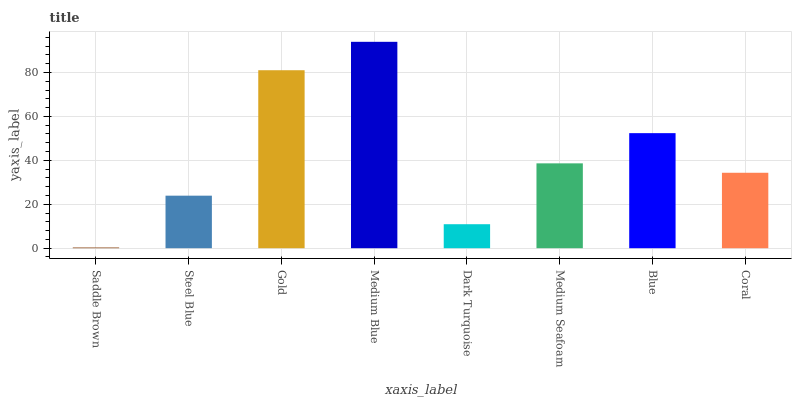Is Saddle Brown the minimum?
Answer yes or no. Yes. Is Medium Blue the maximum?
Answer yes or no. Yes. Is Steel Blue the minimum?
Answer yes or no. No. Is Steel Blue the maximum?
Answer yes or no. No. Is Steel Blue greater than Saddle Brown?
Answer yes or no. Yes. Is Saddle Brown less than Steel Blue?
Answer yes or no. Yes. Is Saddle Brown greater than Steel Blue?
Answer yes or no. No. Is Steel Blue less than Saddle Brown?
Answer yes or no. No. Is Medium Seafoam the high median?
Answer yes or no. Yes. Is Coral the low median?
Answer yes or no. Yes. Is Saddle Brown the high median?
Answer yes or no. No. Is Gold the low median?
Answer yes or no. No. 